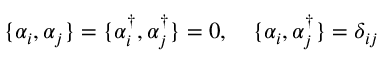<formula> <loc_0><loc_0><loc_500><loc_500>\begin{array} { r } { \{ \alpha _ { i } , \alpha _ { j } \} = \{ \alpha _ { i } ^ { \dagger } , \alpha _ { j } ^ { \dagger } \} = 0 , \quad \{ \alpha _ { i } , \alpha _ { j } ^ { \dagger } \} = \delta _ { i j } } \end{array}</formula> 